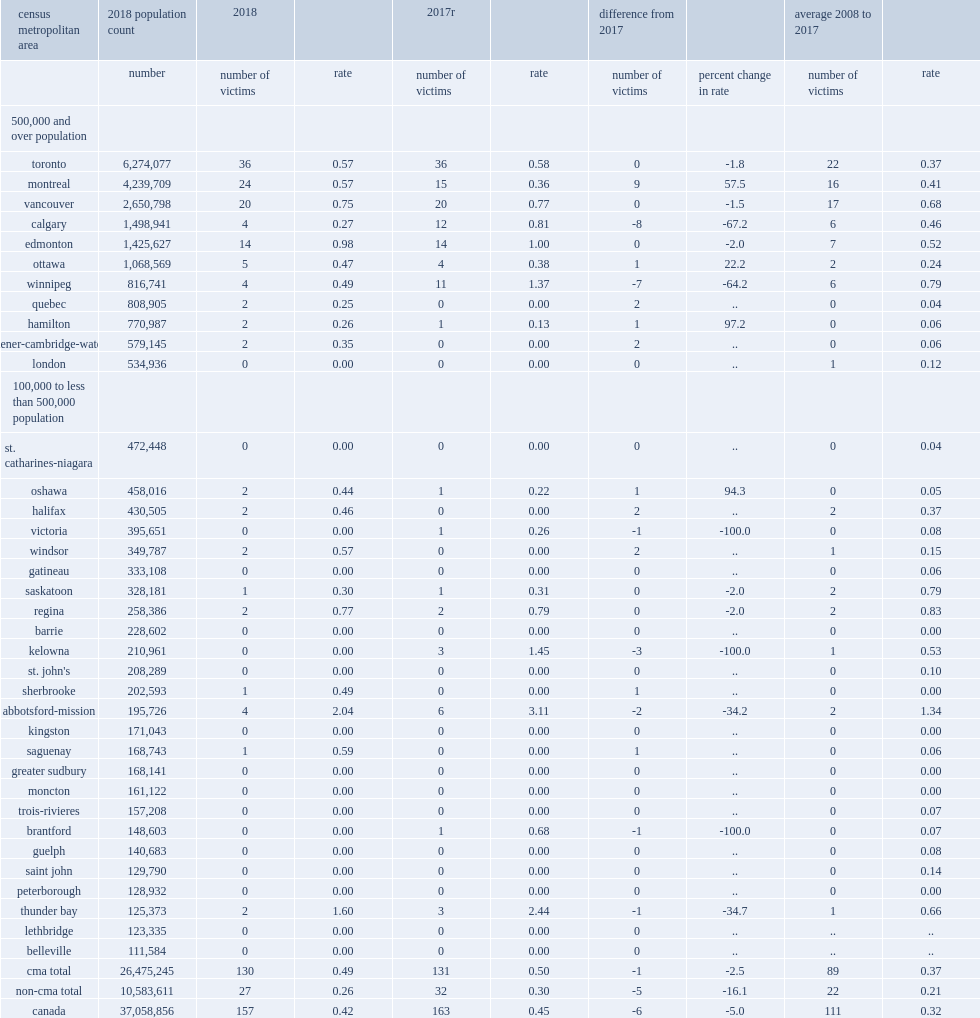What was the number of decrease of gang-related homicides from 2017 in calgary? -8.0. What was the number of gang-related homicides in the census metropolitan area of toronto in 2018? 36.0. 